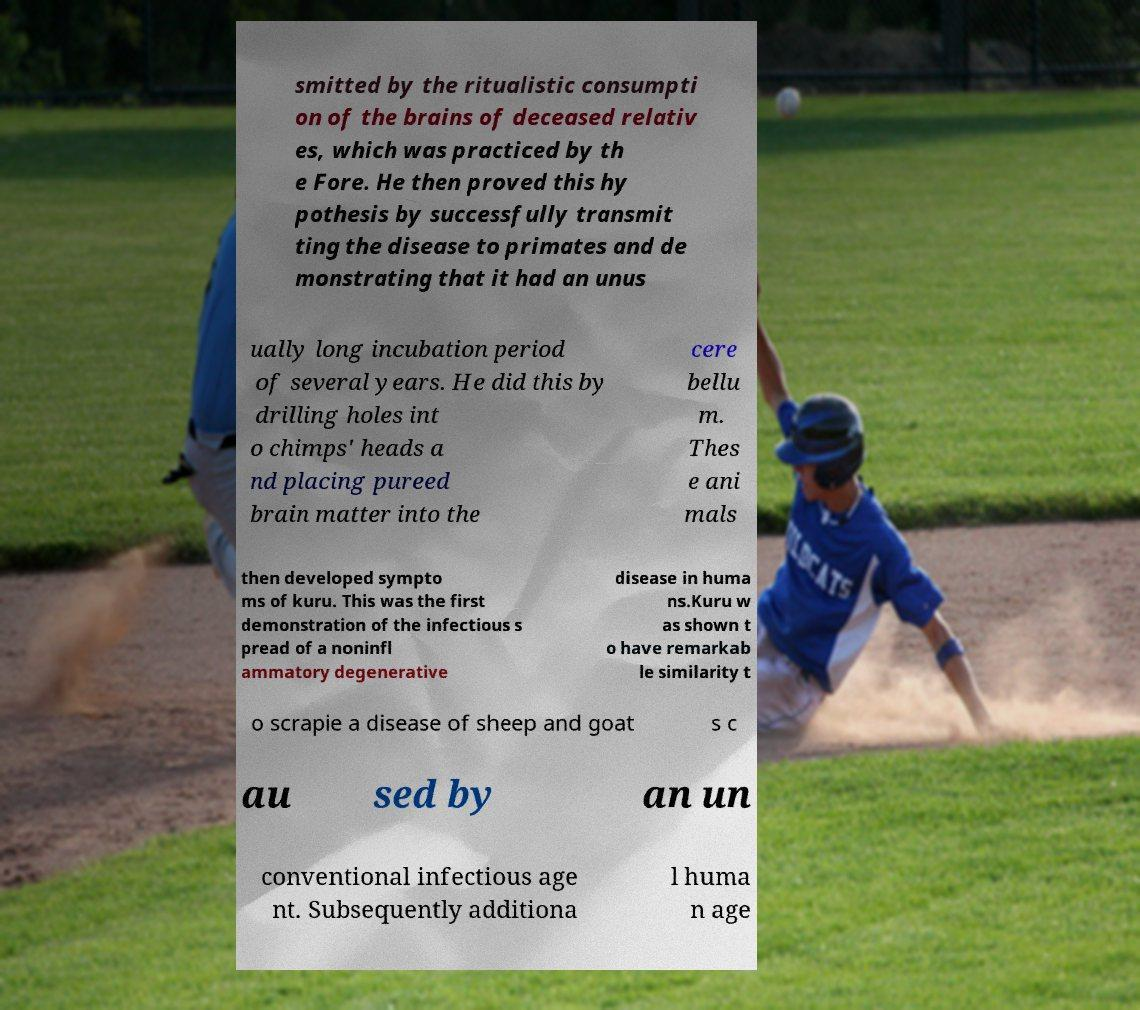Please identify and transcribe the text found in this image. smitted by the ritualistic consumpti on of the brains of deceased relativ es, which was practiced by th e Fore. He then proved this hy pothesis by successfully transmit ting the disease to primates and de monstrating that it had an unus ually long incubation period of several years. He did this by drilling holes int o chimps' heads a nd placing pureed brain matter into the cere bellu m. Thes e ani mals then developed sympto ms of kuru. This was the first demonstration of the infectious s pread of a noninfl ammatory degenerative disease in huma ns.Kuru w as shown t o have remarkab le similarity t o scrapie a disease of sheep and goat s c au sed by an un conventional infectious age nt. Subsequently additiona l huma n age 